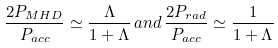<formula> <loc_0><loc_0><loc_500><loc_500>\frac { 2 P _ { M H D } } { P _ { a c c } } \simeq \frac { \Lambda } { 1 + \Lambda } \, a n d \, \frac { 2 P _ { r a d } } { P _ { a c c } } \simeq \frac { 1 } { 1 + \Lambda }</formula> 